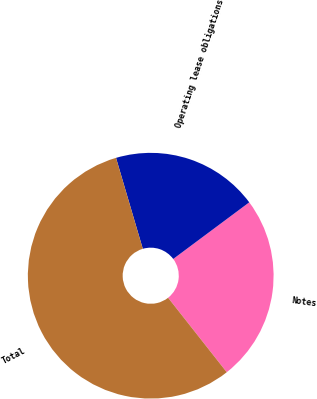Convert chart. <chart><loc_0><loc_0><loc_500><loc_500><pie_chart><fcel>Notes<fcel>Operating lease obligations<fcel>Total<nl><fcel>24.57%<fcel>19.37%<fcel>56.06%<nl></chart> 